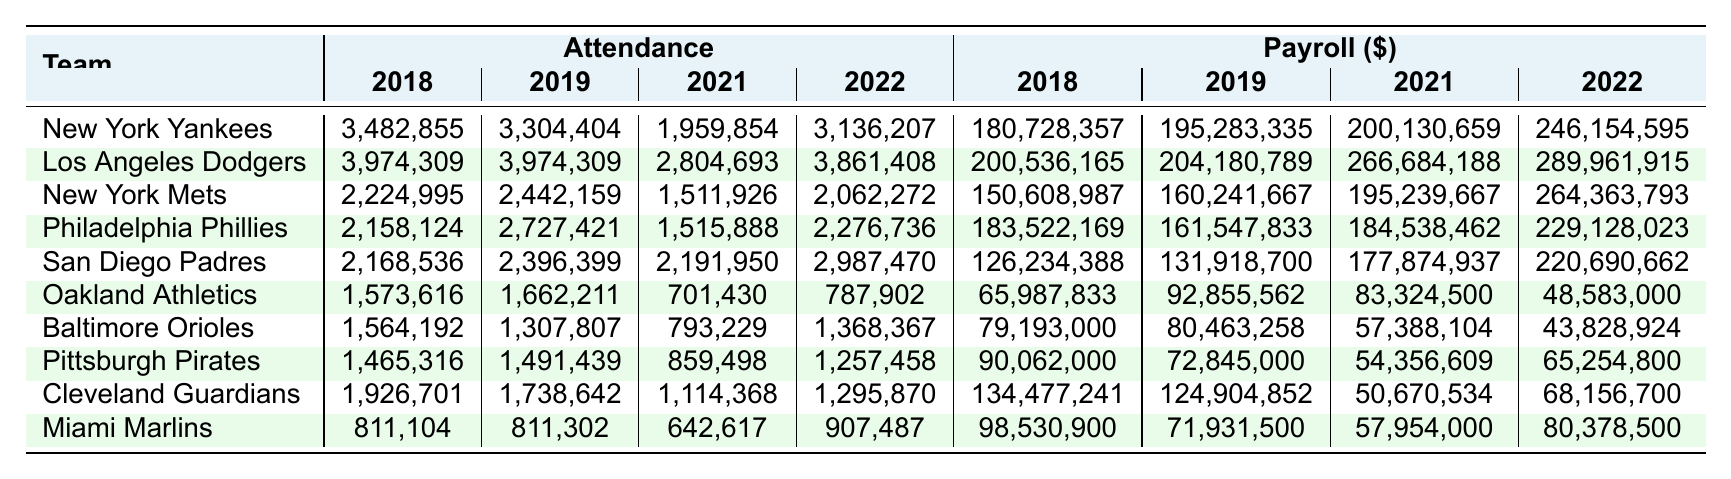What was the highest attendance recorded for the New York Yankees? In the attendance row for the New York Yankees, the highest value is found in 2018 at 3,482,855.
Answer: 3,482,855 Which team had the lowest payroll in 2022? Looking through the payroll figures for 2022, the Oakland Athletics have the lowest value at 48,583,000.
Answer: 48,583,000 What was the average attendance for the Los Angeles Dodgers over the four years? To find the average, sum the attendances: (3,974,309 + 3,974,309 + 2,804,693 + 3,861,408) = 14,614,719. Divide by 4 (the number of years) results in 14,614,719 / 4 = 3,653,679.75.
Answer: 3,653,679.75 How much did the Miami Marlins increase their attendance from 2021 to 2022? The attendance in 2022 is 907,487 and in 2021 it is 642,617. The increase is calculated as 907,487 - 642,617 = 264,870.
Answer: 264,870 Is it true that the New York Mets had a higher attendance than the Pittsburgh Pirates in 2021? The New York Mets had an attendance of 1,511,926, while the Pittsburgh Pirates had an attendance of 859,498 in 2021, confirming that the Mets had a higher attendance.
Answer: Yes What is the total payroll of the Philadelphia Phillies across the four years? Adding the payroll figures for the Philadelphia Phillies: (183,522,169 + 161,547,833 + 184,538,462 + 229,128,023) = 760,736,487.
Answer: 760,736,487 Which team had the highest attendance in 2021 and what was that figure? The highest attendance in 2021 is found by comparing every team's attendance: the New York Yankees had 1,959,854, and the Los Angeles Dodgers had 2,804,693. The Dodgers had the highest attendance of 2,804,693.
Answer: 2,804,693 What is the difference in payroll between the San Diego Padres and the Miami Marlins in 2022? The payroll for San Diego Padres in 2022 is 220,690,662 while for the Miami Marlins it is 80,378,500. The difference is 220,690,662 - 80,378,500 = 140,312,162.
Answer: 140,312,162 Which team had the most consistent attendance between years, showing the smallest variation? The attendance for the Los Angeles Dodgers shows no variation in 2018 and 2019 at 3,974,309, while other teams like the Oakland Athletics show significant changes. Thus, the Dodgers had the most consistent attendance in those years.
Answer: Los Angeles Dodgers In which year did the Baltimore Orioles have the highest attendance? By checking the attendance figures, the Baltimore Orioles had the highest attendance in 2019 at 1,307,807.
Answer: 2019 